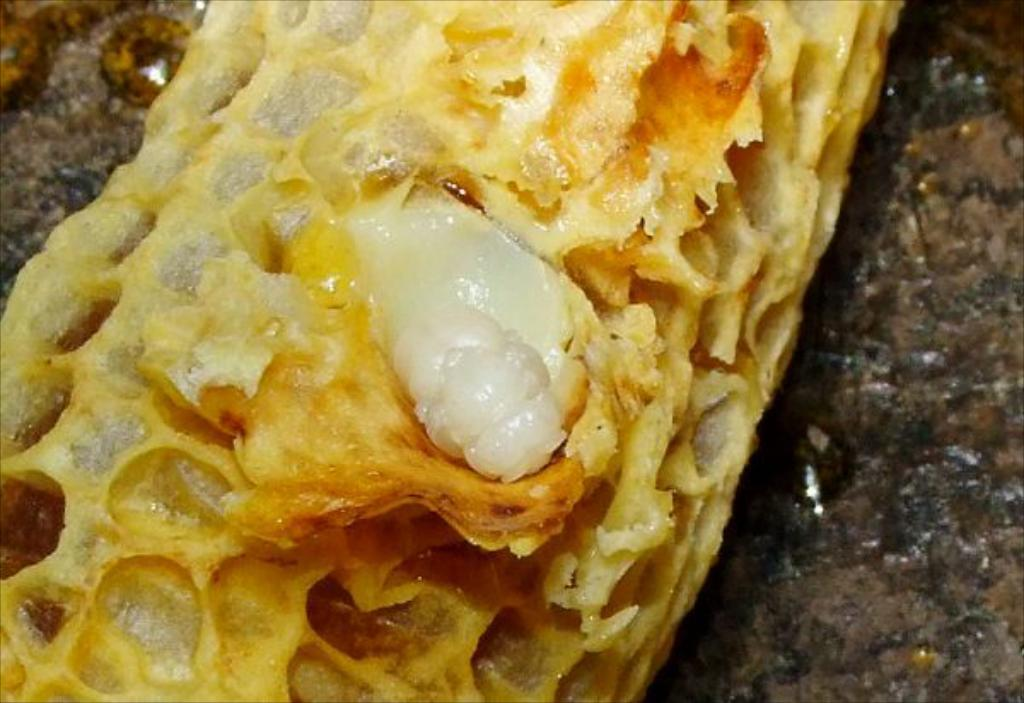What is the main subject of the image? There is a food item in the image. How many rings are visible on the food item in the image? There are no rings present on the food item in the image. What type of cloud is depicted above the food item in the image? There is no cloud present in the image, as it only features a food item. 